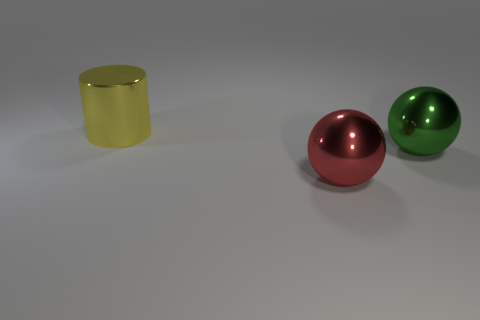Add 3 large things. How many objects exist? 6 Subtract all spheres. How many objects are left? 1 Subtract 0 red cubes. How many objects are left? 3 Subtract all green things. Subtract all blocks. How many objects are left? 2 Add 2 yellow objects. How many yellow objects are left? 3 Add 2 green spheres. How many green spheres exist? 3 